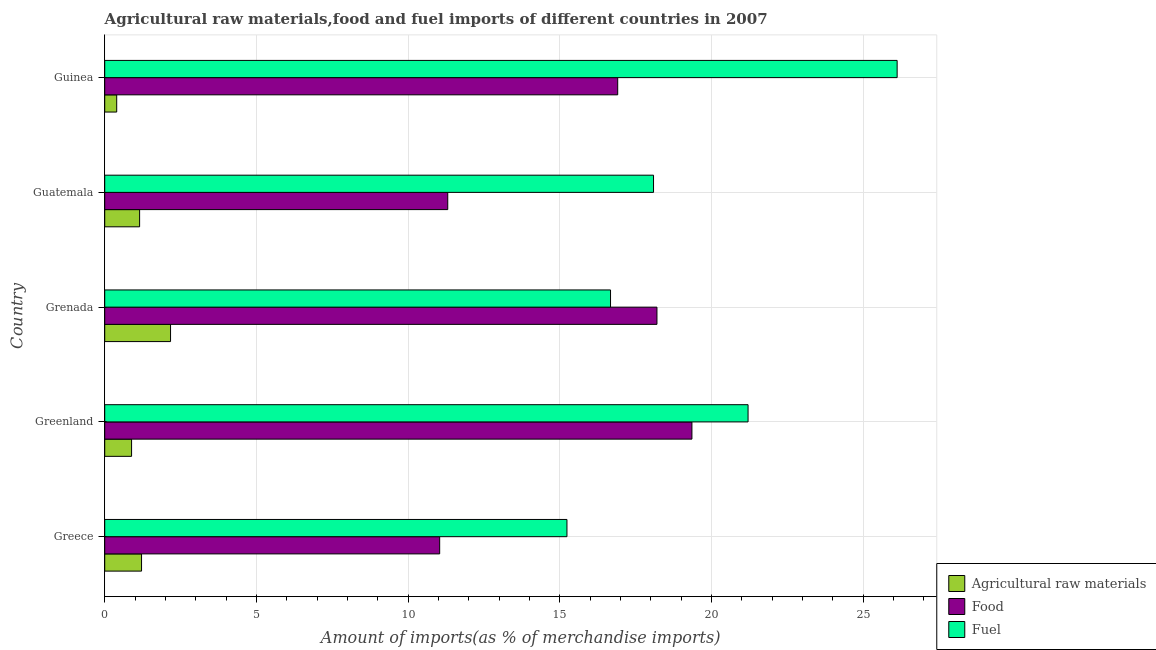How many different coloured bars are there?
Provide a short and direct response. 3. How many groups of bars are there?
Provide a succinct answer. 5. Are the number of bars on each tick of the Y-axis equal?
Provide a short and direct response. Yes. How many bars are there on the 1st tick from the top?
Your answer should be compact. 3. What is the label of the 2nd group of bars from the top?
Provide a short and direct response. Guatemala. What is the percentage of raw materials imports in Greenland?
Ensure brevity in your answer.  0.89. Across all countries, what is the maximum percentage of food imports?
Offer a terse response. 19.36. Across all countries, what is the minimum percentage of fuel imports?
Offer a very short reply. 15.24. In which country was the percentage of raw materials imports maximum?
Offer a terse response. Grenada. In which country was the percentage of food imports minimum?
Keep it short and to the point. Greece. What is the total percentage of raw materials imports in the graph?
Give a very brief answer. 5.82. What is the difference between the percentage of raw materials imports in Greece and that in Guatemala?
Offer a very short reply. 0.06. What is the difference between the percentage of raw materials imports in Grenada and the percentage of food imports in Guinea?
Ensure brevity in your answer.  -14.74. What is the average percentage of fuel imports per country?
Your response must be concise. 19.47. What is the difference between the percentage of raw materials imports and percentage of food imports in Greenland?
Provide a short and direct response. -18.47. In how many countries, is the percentage of raw materials imports greater than 17 %?
Your response must be concise. 0. What is the ratio of the percentage of food imports in Greece to that in Guinea?
Your answer should be very brief. 0.65. Is the difference between the percentage of food imports in Greece and Guatemala greater than the difference between the percentage of fuel imports in Greece and Guatemala?
Keep it short and to the point. Yes. What is the difference between the highest and the second highest percentage of raw materials imports?
Offer a terse response. 0.96. What is the difference between the highest and the lowest percentage of fuel imports?
Offer a very short reply. 10.89. Is the sum of the percentage of raw materials imports in Greenland and Guatemala greater than the maximum percentage of food imports across all countries?
Your answer should be very brief. No. What does the 1st bar from the top in Greenland represents?
Make the answer very short. Fuel. What does the 1st bar from the bottom in Guatemala represents?
Provide a short and direct response. Agricultural raw materials. Is it the case that in every country, the sum of the percentage of raw materials imports and percentage of food imports is greater than the percentage of fuel imports?
Provide a succinct answer. No. Are all the bars in the graph horizontal?
Offer a very short reply. Yes. How many countries are there in the graph?
Provide a short and direct response. 5. Does the graph contain grids?
Offer a very short reply. Yes. Where does the legend appear in the graph?
Give a very brief answer. Bottom right. How many legend labels are there?
Your answer should be very brief. 3. What is the title of the graph?
Ensure brevity in your answer.  Agricultural raw materials,food and fuel imports of different countries in 2007. What is the label or title of the X-axis?
Keep it short and to the point. Amount of imports(as % of merchandise imports). What is the label or title of the Y-axis?
Your answer should be very brief. Country. What is the Amount of imports(as % of merchandise imports) of Agricultural raw materials in Greece?
Offer a very short reply. 1.21. What is the Amount of imports(as % of merchandise imports) in Food in Greece?
Provide a succinct answer. 11.04. What is the Amount of imports(as % of merchandise imports) in Fuel in Greece?
Make the answer very short. 15.24. What is the Amount of imports(as % of merchandise imports) of Agricultural raw materials in Greenland?
Offer a very short reply. 0.89. What is the Amount of imports(as % of merchandise imports) of Food in Greenland?
Provide a short and direct response. 19.36. What is the Amount of imports(as % of merchandise imports) in Fuel in Greenland?
Provide a short and direct response. 21.21. What is the Amount of imports(as % of merchandise imports) of Agricultural raw materials in Grenada?
Your response must be concise. 2.17. What is the Amount of imports(as % of merchandise imports) of Food in Grenada?
Your answer should be compact. 18.21. What is the Amount of imports(as % of merchandise imports) in Fuel in Grenada?
Your answer should be very brief. 16.68. What is the Amount of imports(as % of merchandise imports) of Agricultural raw materials in Guatemala?
Provide a short and direct response. 1.15. What is the Amount of imports(as % of merchandise imports) in Food in Guatemala?
Your answer should be very brief. 11.31. What is the Amount of imports(as % of merchandise imports) of Fuel in Guatemala?
Provide a succinct answer. 18.09. What is the Amount of imports(as % of merchandise imports) of Agricultural raw materials in Guinea?
Provide a short and direct response. 0.4. What is the Amount of imports(as % of merchandise imports) in Food in Guinea?
Provide a short and direct response. 16.91. What is the Amount of imports(as % of merchandise imports) of Fuel in Guinea?
Your answer should be compact. 26.12. Across all countries, what is the maximum Amount of imports(as % of merchandise imports) of Agricultural raw materials?
Your answer should be compact. 2.17. Across all countries, what is the maximum Amount of imports(as % of merchandise imports) of Food?
Your response must be concise. 19.36. Across all countries, what is the maximum Amount of imports(as % of merchandise imports) in Fuel?
Give a very brief answer. 26.12. Across all countries, what is the minimum Amount of imports(as % of merchandise imports) of Agricultural raw materials?
Provide a succinct answer. 0.4. Across all countries, what is the minimum Amount of imports(as % of merchandise imports) of Food?
Provide a succinct answer. 11.04. Across all countries, what is the minimum Amount of imports(as % of merchandise imports) of Fuel?
Offer a very short reply. 15.24. What is the total Amount of imports(as % of merchandise imports) in Agricultural raw materials in the graph?
Provide a short and direct response. 5.82. What is the total Amount of imports(as % of merchandise imports) in Food in the graph?
Make the answer very short. 76.83. What is the total Amount of imports(as % of merchandise imports) of Fuel in the graph?
Give a very brief answer. 97.34. What is the difference between the Amount of imports(as % of merchandise imports) of Agricultural raw materials in Greece and that in Greenland?
Your response must be concise. 0.33. What is the difference between the Amount of imports(as % of merchandise imports) of Food in Greece and that in Greenland?
Provide a short and direct response. -8.32. What is the difference between the Amount of imports(as % of merchandise imports) of Fuel in Greece and that in Greenland?
Your response must be concise. -5.97. What is the difference between the Amount of imports(as % of merchandise imports) in Agricultural raw materials in Greece and that in Grenada?
Give a very brief answer. -0.96. What is the difference between the Amount of imports(as % of merchandise imports) in Food in Greece and that in Grenada?
Your answer should be compact. -7.16. What is the difference between the Amount of imports(as % of merchandise imports) of Fuel in Greece and that in Grenada?
Your answer should be compact. -1.44. What is the difference between the Amount of imports(as % of merchandise imports) in Agricultural raw materials in Greece and that in Guatemala?
Your answer should be very brief. 0.06. What is the difference between the Amount of imports(as % of merchandise imports) of Food in Greece and that in Guatemala?
Provide a short and direct response. -0.27. What is the difference between the Amount of imports(as % of merchandise imports) in Fuel in Greece and that in Guatemala?
Provide a short and direct response. -2.85. What is the difference between the Amount of imports(as % of merchandise imports) of Agricultural raw materials in Greece and that in Guinea?
Offer a very short reply. 0.82. What is the difference between the Amount of imports(as % of merchandise imports) in Food in Greece and that in Guinea?
Provide a succinct answer. -5.87. What is the difference between the Amount of imports(as % of merchandise imports) in Fuel in Greece and that in Guinea?
Make the answer very short. -10.89. What is the difference between the Amount of imports(as % of merchandise imports) in Agricultural raw materials in Greenland and that in Grenada?
Offer a very short reply. -1.28. What is the difference between the Amount of imports(as % of merchandise imports) of Food in Greenland and that in Grenada?
Provide a short and direct response. 1.15. What is the difference between the Amount of imports(as % of merchandise imports) of Fuel in Greenland and that in Grenada?
Your response must be concise. 4.53. What is the difference between the Amount of imports(as % of merchandise imports) in Agricultural raw materials in Greenland and that in Guatemala?
Your answer should be very brief. -0.26. What is the difference between the Amount of imports(as % of merchandise imports) in Food in Greenland and that in Guatemala?
Provide a succinct answer. 8.05. What is the difference between the Amount of imports(as % of merchandise imports) in Fuel in Greenland and that in Guatemala?
Keep it short and to the point. 3.12. What is the difference between the Amount of imports(as % of merchandise imports) in Agricultural raw materials in Greenland and that in Guinea?
Provide a short and direct response. 0.49. What is the difference between the Amount of imports(as % of merchandise imports) of Food in Greenland and that in Guinea?
Keep it short and to the point. 2.45. What is the difference between the Amount of imports(as % of merchandise imports) of Fuel in Greenland and that in Guinea?
Provide a succinct answer. -4.91. What is the difference between the Amount of imports(as % of merchandise imports) of Agricultural raw materials in Grenada and that in Guatemala?
Your response must be concise. 1.02. What is the difference between the Amount of imports(as % of merchandise imports) in Food in Grenada and that in Guatemala?
Provide a short and direct response. 6.9. What is the difference between the Amount of imports(as % of merchandise imports) in Fuel in Grenada and that in Guatemala?
Give a very brief answer. -1.42. What is the difference between the Amount of imports(as % of merchandise imports) in Agricultural raw materials in Grenada and that in Guinea?
Offer a very short reply. 1.78. What is the difference between the Amount of imports(as % of merchandise imports) of Food in Grenada and that in Guinea?
Give a very brief answer. 1.29. What is the difference between the Amount of imports(as % of merchandise imports) in Fuel in Grenada and that in Guinea?
Provide a short and direct response. -9.45. What is the difference between the Amount of imports(as % of merchandise imports) in Agricultural raw materials in Guatemala and that in Guinea?
Keep it short and to the point. 0.76. What is the difference between the Amount of imports(as % of merchandise imports) in Food in Guatemala and that in Guinea?
Provide a succinct answer. -5.6. What is the difference between the Amount of imports(as % of merchandise imports) in Fuel in Guatemala and that in Guinea?
Your answer should be compact. -8.03. What is the difference between the Amount of imports(as % of merchandise imports) of Agricultural raw materials in Greece and the Amount of imports(as % of merchandise imports) of Food in Greenland?
Your response must be concise. -18.14. What is the difference between the Amount of imports(as % of merchandise imports) of Agricultural raw materials in Greece and the Amount of imports(as % of merchandise imports) of Fuel in Greenland?
Keep it short and to the point. -20. What is the difference between the Amount of imports(as % of merchandise imports) in Food in Greece and the Amount of imports(as % of merchandise imports) in Fuel in Greenland?
Your response must be concise. -10.17. What is the difference between the Amount of imports(as % of merchandise imports) of Agricultural raw materials in Greece and the Amount of imports(as % of merchandise imports) of Food in Grenada?
Make the answer very short. -16.99. What is the difference between the Amount of imports(as % of merchandise imports) of Agricultural raw materials in Greece and the Amount of imports(as % of merchandise imports) of Fuel in Grenada?
Your answer should be compact. -15.46. What is the difference between the Amount of imports(as % of merchandise imports) in Food in Greece and the Amount of imports(as % of merchandise imports) in Fuel in Grenada?
Provide a succinct answer. -5.63. What is the difference between the Amount of imports(as % of merchandise imports) of Agricultural raw materials in Greece and the Amount of imports(as % of merchandise imports) of Food in Guatemala?
Offer a very short reply. -10.09. What is the difference between the Amount of imports(as % of merchandise imports) of Agricultural raw materials in Greece and the Amount of imports(as % of merchandise imports) of Fuel in Guatemala?
Make the answer very short. -16.88. What is the difference between the Amount of imports(as % of merchandise imports) of Food in Greece and the Amount of imports(as % of merchandise imports) of Fuel in Guatemala?
Give a very brief answer. -7.05. What is the difference between the Amount of imports(as % of merchandise imports) in Agricultural raw materials in Greece and the Amount of imports(as % of merchandise imports) in Food in Guinea?
Your answer should be very brief. -15.7. What is the difference between the Amount of imports(as % of merchandise imports) of Agricultural raw materials in Greece and the Amount of imports(as % of merchandise imports) of Fuel in Guinea?
Offer a terse response. -24.91. What is the difference between the Amount of imports(as % of merchandise imports) of Food in Greece and the Amount of imports(as % of merchandise imports) of Fuel in Guinea?
Offer a very short reply. -15.08. What is the difference between the Amount of imports(as % of merchandise imports) of Agricultural raw materials in Greenland and the Amount of imports(as % of merchandise imports) of Food in Grenada?
Your answer should be compact. -17.32. What is the difference between the Amount of imports(as % of merchandise imports) in Agricultural raw materials in Greenland and the Amount of imports(as % of merchandise imports) in Fuel in Grenada?
Keep it short and to the point. -15.79. What is the difference between the Amount of imports(as % of merchandise imports) in Food in Greenland and the Amount of imports(as % of merchandise imports) in Fuel in Grenada?
Provide a short and direct response. 2.68. What is the difference between the Amount of imports(as % of merchandise imports) of Agricultural raw materials in Greenland and the Amount of imports(as % of merchandise imports) of Food in Guatemala?
Make the answer very short. -10.42. What is the difference between the Amount of imports(as % of merchandise imports) of Agricultural raw materials in Greenland and the Amount of imports(as % of merchandise imports) of Fuel in Guatemala?
Ensure brevity in your answer.  -17.21. What is the difference between the Amount of imports(as % of merchandise imports) in Food in Greenland and the Amount of imports(as % of merchandise imports) in Fuel in Guatemala?
Offer a terse response. 1.27. What is the difference between the Amount of imports(as % of merchandise imports) of Agricultural raw materials in Greenland and the Amount of imports(as % of merchandise imports) of Food in Guinea?
Your answer should be very brief. -16.03. What is the difference between the Amount of imports(as % of merchandise imports) in Agricultural raw materials in Greenland and the Amount of imports(as % of merchandise imports) in Fuel in Guinea?
Provide a succinct answer. -25.24. What is the difference between the Amount of imports(as % of merchandise imports) in Food in Greenland and the Amount of imports(as % of merchandise imports) in Fuel in Guinea?
Offer a terse response. -6.77. What is the difference between the Amount of imports(as % of merchandise imports) in Agricultural raw materials in Grenada and the Amount of imports(as % of merchandise imports) in Food in Guatemala?
Your response must be concise. -9.14. What is the difference between the Amount of imports(as % of merchandise imports) of Agricultural raw materials in Grenada and the Amount of imports(as % of merchandise imports) of Fuel in Guatemala?
Ensure brevity in your answer.  -15.92. What is the difference between the Amount of imports(as % of merchandise imports) in Food in Grenada and the Amount of imports(as % of merchandise imports) in Fuel in Guatemala?
Ensure brevity in your answer.  0.11. What is the difference between the Amount of imports(as % of merchandise imports) of Agricultural raw materials in Grenada and the Amount of imports(as % of merchandise imports) of Food in Guinea?
Your answer should be very brief. -14.74. What is the difference between the Amount of imports(as % of merchandise imports) in Agricultural raw materials in Grenada and the Amount of imports(as % of merchandise imports) in Fuel in Guinea?
Make the answer very short. -23.95. What is the difference between the Amount of imports(as % of merchandise imports) of Food in Grenada and the Amount of imports(as % of merchandise imports) of Fuel in Guinea?
Keep it short and to the point. -7.92. What is the difference between the Amount of imports(as % of merchandise imports) of Agricultural raw materials in Guatemala and the Amount of imports(as % of merchandise imports) of Food in Guinea?
Your answer should be compact. -15.76. What is the difference between the Amount of imports(as % of merchandise imports) in Agricultural raw materials in Guatemala and the Amount of imports(as % of merchandise imports) in Fuel in Guinea?
Keep it short and to the point. -24.97. What is the difference between the Amount of imports(as % of merchandise imports) in Food in Guatemala and the Amount of imports(as % of merchandise imports) in Fuel in Guinea?
Keep it short and to the point. -14.81. What is the average Amount of imports(as % of merchandise imports) of Agricultural raw materials per country?
Offer a very short reply. 1.16. What is the average Amount of imports(as % of merchandise imports) of Food per country?
Ensure brevity in your answer.  15.37. What is the average Amount of imports(as % of merchandise imports) of Fuel per country?
Your answer should be compact. 19.47. What is the difference between the Amount of imports(as % of merchandise imports) of Agricultural raw materials and Amount of imports(as % of merchandise imports) of Food in Greece?
Give a very brief answer. -9.83. What is the difference between the Amount of imports(as % of merchandise imports) in Agricultural raw materials and Amount of imports(as % of merchandise imports) in Fuel in Greece?
Provide a short and direct response. -14.02. What is the difference between the Amount of imports(as % of merchandise imports) of Food and Amount of imports(as % of merchandise imports) of Fuel in Greece?
Your answer should be very brief. -4.2. What is the difference between the Amount of imports(as % of merchandise imports) of Agricultural raw materials and Amount of imports(as % of merchandise imports) of Food in Greenland?
Provide a short and direct response. -18.47. What is the difference between the Amount of imports(as % of merchandise imports) of Agricultural raw materials and Amount of imports(as % of merchandise imports) of Fuel in Greenland?
Ensure brevity in your answer.  -20.32. What is the difference between the Amount of imports(as % of merchandise imports) in Food and Amount of imports(as % of merchandise imports) in Fuel in Greenland?
Make the answer very short. -1.85. What is the difference between the Amount of imports(as % of merchandise imports) in Agricultural raw materials and Amount of imports(as % of merchandise imports) in Food in Grenada?
Provide a short and direct response. -16.04. What is the difference between the Amount of imports(as % of merchandise imports) in Agricultural raw materials and Amount of imports(as % of merchandise imports) in Fuel in Grenada?
Provide a short and direct response. -14.51. What is the difference between the Amount of imports(as % of merchandise imports) in Food and Amount of imports(as % of merchandise imports) in Fuel in Grenada?
Give a very brief answer. 1.53. What is the difference between the Amount of imports(as % of merchandise imports) of Agricultural raw materials and Amount of imports(as % of merchandise imports) of Food in Guatemala?
Offer a terse response. -10.16. What is the difference between the Amount of imports(as % of merchandise imports) of Agricultural raw materials and Amount of imports(as % of merchandise imports) of Fuel in Guatemala?
Keep it short and to the point. -16.94. What is the difference between the Amount of imports(as % of merchandise imports) in Food and Amount of imports(as % of merchandise imports) in Fuel in Guatemala?
Your answer should be compact. -6.78. What is the difference between the Amount of imports(as % of merchandise imports) of Agricultural raw materials and Amount of imports(as % of merchandise imports) of Food in Guinea?
Make the answer very short. -16.52. What is the difference between the Amount of imports(as % of merchandise imports) in Agricultural raw materials and Amount of imports(as % of merchandise imports) in Fuel in Guinea?
Offer a very short reply. -25.73. What is the difference between the Amount of imports(as % of merchandise imports) of Food and Amount of imports(as % of merchandise imports) of Fuel in Guinea?
Offer a terse response. -9.21. What is the ratio of the Amount of imports(as % of merchandise imports) in Agricultural raw materials in Greece to that in Greenland?
Offer a very short reply. 1.37. What is the ratio of the Amount of imports(as % of merchandise imports) of Food in Greece to that in Greenland?
Provide a succinct answer. 0.57. What is the ratio of the Amount of imports(as % of merchandise imports) in Fuel in Greece to that in Greenland?
Your answer should be compact. 0.72. What is the ratio of the Amount of imports(as % of merchandise imports) in Agricultural raw materials in Greece to that in Grenada?
Your response must be concise. 0.56. What is the ratio of the Amount of imports(as % of merchandise imports) in Food in Greece to that in Grenada?
Provide a short and direct response. 0.61. What is the ratio of the Amount of imports(as % of merchandise imports) of Fuel in Greece to that in Grenada?
Keep it short and to the point. 0.91. What is the ratio of the Amount of imports(as % of merchandise imports) in Agricultural raw materials in Greece to that in Guatemala?
Offer a very short reply. 1.06. What is the ratio of the Amount of imports(as % of merchandise imports) in Food in Greece to that in Guatemala?
Offer a very short reply. 0.98. What is the ratio of the Amount of imports(as % of merchandise imports) in Fuel in Greece to that in Guatemala?
Keep it short and to the point. 0.84. What is the ratio of the Amount of imports(as % of merchandise imports) in Agricultural raw materials in Greece to that in Guinea?
Your answer should be very brief. 3.07. What is the ratio of the Amount of imports(as % of merchandise imports) in Food in Greece to that in Guinea?
Make the answer very short. 0.65. What is the ratio of the Amount of imports(as % of merchandise imports) of Fuel in Greece to that in Guinea?
Make the answer very short. 0.58. What is the ratio of the Amount of imports(as % of merchandise imports) of Agricultural raw materials in Greenland to that in Grenada?
Ensure brevity in your answer.  0.41. What is the ratio of the Amount of imports(as % of merchandise imports) in Food in Greenland to that in Grenada?
Give a very brief answer. 1.06. What is the ratio of the Amount of imports(as % of merchandise imports) in Fuel in Greenland to that in Grenada?
Offer a terse response. 1.27. What is the ratio of the Amount of imports(as % of merchandise imports) of Agricultural raw materials in Greenland to that in Guatemala?
Make the answer very short. 0.77. What is the ratio of the Amount of imports(as % of merchandise imports) of Food in Greenland to that in Guatemala?
Make the answer very short. 1.71. What is the ratio of the Amount of imports(as % of merchandise imports) of Fuel in Greenland to that in Guatemala?
Provide a succinct answer. 1.17. What is the ratio of the Amount of imports(as % of merchandise imports) in Agricultural raw materials in Greenland to that in Guinea?
Offer a terse response. 2.24. What is the ratio of the Amount of imports(as % of merchandise imports) in Food in Greenland to that in Guinea?
Offer a terse response. 1.14. What is the ratio of the Amount of imports(as % of merchandise imports) in Fuel in Greenland to that in Guinea?
Offer a very short reply. 0.81. What is the ratio of the Amount of imports(as % of merchandise imports) of Agricultural raw materials in Grenada to that in Guatemala?
Your response must be concise. 1.89. What is the ratio of the Amount of imports(as % of merchandise imports) of Food in Grenada to that in Guatemala?
Offer a terse response. 1.61. What is the ratio of the Amount of imports(as % of merchandise imports) of Fuel in Grenada to that in Guatemala?
Give a very brief answer. 0.92. What is the ratio of the Amount of imports(as % of merchandise imports) of Agricultural raw materials in Grenada to that in Guinea?
Give a very brief answer. 5.49. What is the ratio of the Amount of imports(as % of merchandise imports) of Food in Grenada to that in Guinea?
Give a very brief answer. 1.08. What is the ratio of the Amount of imports(as % of merchandise imports) of Fuel in Grenada to that in Guinea?
Keep it short and to the point. 0.64. What is the ratio of the Amount of imports(as % of merchandise imports) in Agricultural raw materials in Guatemala to that in Guinea?
Offer a terse response. 2.91. What is the ratio of the Amount of imports(as % of merchandise imports) in Food in Guatemala to that in Guinea?
Ensure brevity in your answer.  0.67. What is the ratio of the Amount of imports(as % of merchandise imports) in Fuel in Guatemala to that in Guinea?
Offer a very short reply. 0.69. What is the difference between the highest and the second highest Amount of imports(as % of merchandise imports) in Agricultural raw materials?
Provide a succinct answer. 0.96. What is the difference between the highest and the second highest Amount of imports(as % of merchandise imports) of Food?
Provide a succinct answer. 1.15. What is the difference between the highest and the second highest Amount of imports(as % of merchandise imports) in Fuel?
Offer a terse response. 4.91. What is the difference between the highest and the lowest Amount of imports(as % of merchandise imports) of Agricultural raw materials?
Make the answer very short. 1.78. What is the difference between the highest and the lowest Amount of imports(as % of merchandise imports) in Food?
Offer a very short reply. 8.32. What is the difference between the highest and the lowest Amount of imports(as % of merchandise imports) of Fuel?
Offer a terse response. 10.89. 